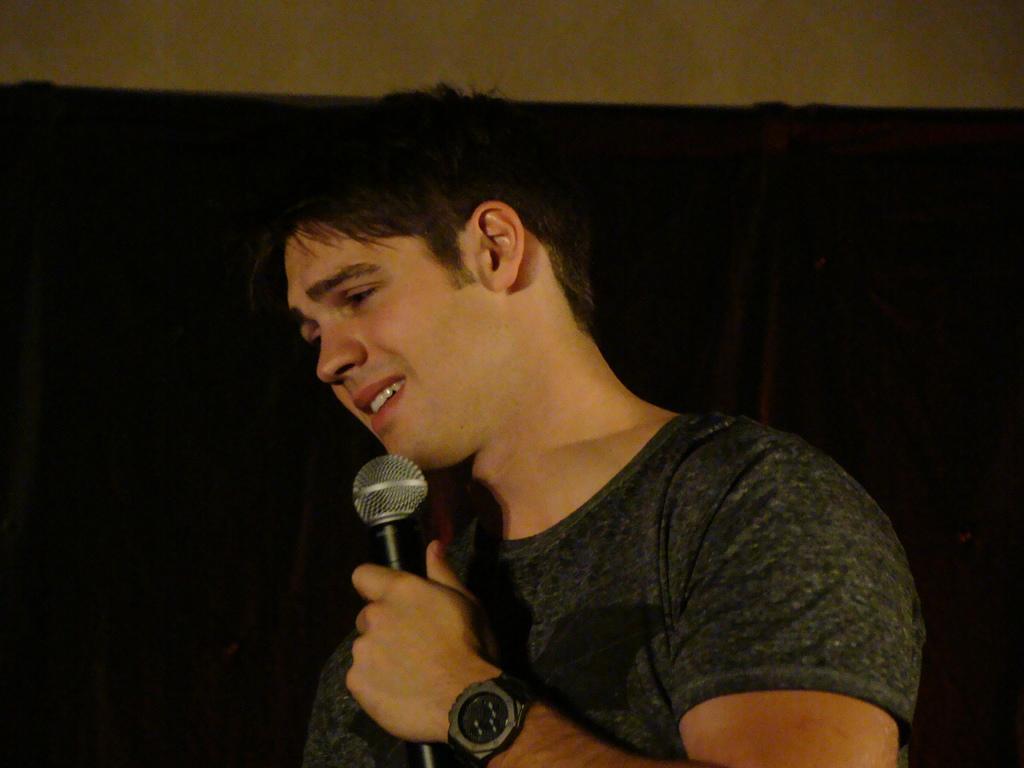How would you summarize this image in a sentence or two? This image shows a man holding a microphone in his left hand and he is speaking. 